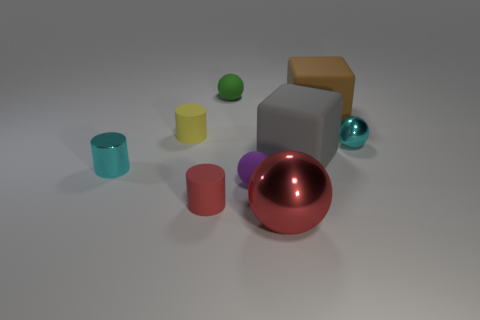Can you describe the composition of the image? Certainly, the composition is carefully balanced with varied geometric shapes strategically placed across the frame. Dynamic contrasts are created through color variation and material differences like matte versus reflective surfaces. Central to the composition is the large metallic sphere, which is complemented by the other objects in varying sizes, shapes, and textures. What atmosphere or mood do you think this composition conveys? The composed scene transmits a sense of calmness and order due to the symmetrical placement of objects and the softness of the lighting. The cool cyan and green hues contribute to a tranquil and modern mood, ideal for illustrating concepts of balance, design, or harmony. 